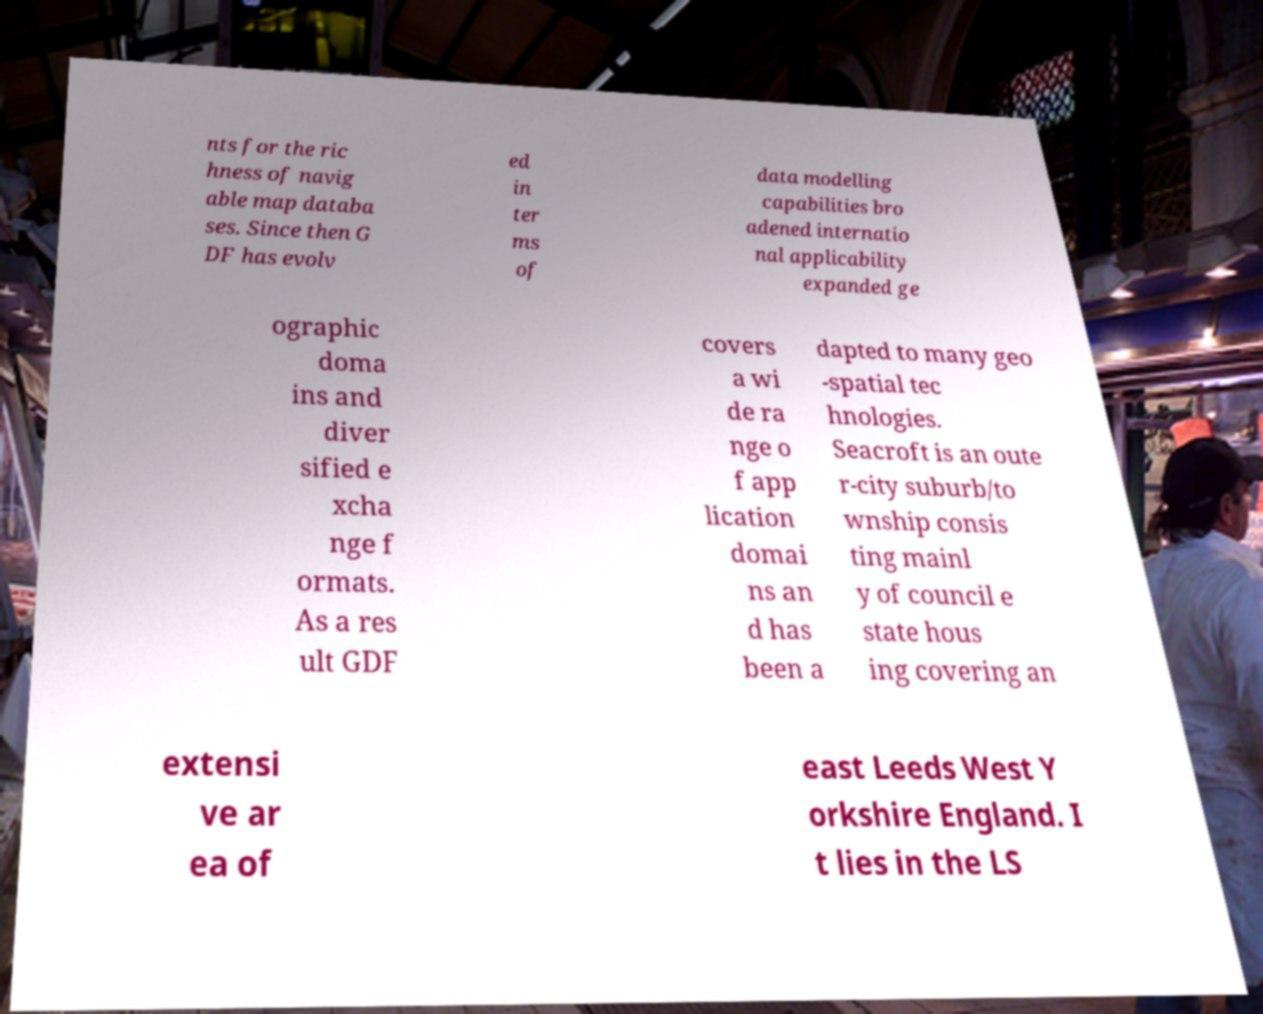Please identify and transcribe the text found in this image. nts for the ric hness of navig able map databa ses. Since then G DF has evolv ed in ter ms of data modelling capabilities bro adened internatio nal applicability expanded ge ographic doma ins and diver sified e xcha nge f ormats. As a res ult GDF covers a wi de ra nge o f app lication domai ns an d has been a dapted to many geo -spatial tec hnologies. Seacroft is an oute r-city suburb/to wnship consis ting mainl y of council e state hous ing covering an extensi ve ar ea of east Leeds West Y orkshire England. I t lies in the LS 